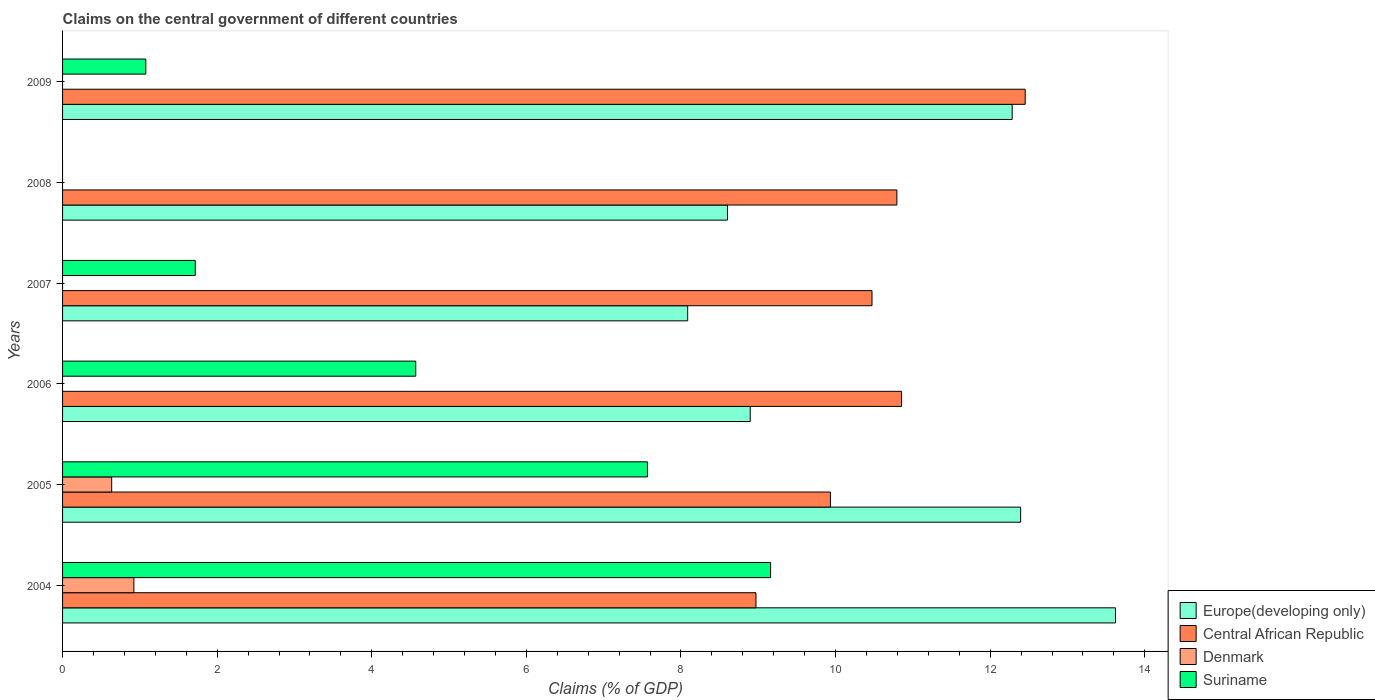How many different coloured bars are there?
Provide a succinct answer. 4. How many groups of bars are there?
Keep it short and to the point. 6. How many bars are there on the 6th tick from the top?
Your answer should be compact. 4. How many bars are there on the 4th tick from the bottom?
Provide a succinct answer. 3. What is the label of the 5th group of bars from the top?
Your answer should be very brief. 2005. In how many cases, is the number of bars for a given year not equal to the number of legend labels?
Your answer should be compact. 4. What is the percentage of GDP claimed on the central government in Denmark in 2007?
Offer a very short reply. 0. Across all years, what is the maximum percentage of GDP claimed on the central government in Suriname?
Your answer should be compact. 9.16. In which year was the percentage of GDP claimed on the central government in Central African Republic maximum?
Give a very brief answer. 2009. What is the total percentage of GDP claimed on the central government in Europe(developing only) in the graph?
Your response must be concise. 63.88. What is the difference between the percentage of GDP claimed on the central government in Central African Republic in 2004 and that in 2005?
Offer a terse response. -0.96. What is the difference between the percentage of GDP claimed on the central government in Denmark in 2004 and the percentage of GDP claimed on the central government in Europe(developing only) in 2006?
Your answer should be very brief. -7.97. What is the average percentage of GDP claimed on the central government in Central African Republic per year?
Provide a succinct answer. 10.58. In the year 2004, what is the difference between the percentage of GDP claimed on the central government in Europe(developing only) and percentage of GDP claimed on the central government in Central African Republic?
Provide a succinct answer. 4.65. What is the ratio of the percentage of GDP claimed on the central government in Europe(developing only) in 2006 to that in 2009?
Give a very brief answer. 0.72. Is the percentage of GDP claimed on the central government in Central African Republic in 2006 less than that in 2007?
Provide a short and direct response. No. Is the difference between the percentage of GDP claimed on the central government in Europe(developing only) in 2004 and 2008 greater than the difference between the percentage of GDP claimed on the central government in Central African Republic in 2004 and 2008?
Offer a terse response. Yes. What is the difference between the highest and the second highest percentage of GDP claimed on the central government in Suriname?
Your response must be concise. 1.59. What is the difference between the highest and the lowest percentage of GDP claimed on the central government in Suriname?
Keep it short and to the point. 9.16. In how many years, is the percentage of GDP claimed on the central government in Suriname greater than the average percentage of GDP claimed on the central government in Suriname taken over all years?
Provide a succinct answer. 3. Is the sum of the percentage of GDP claimed on the central government in Europe(developing only) in 2006 and 2008 greater than the maximum percentage of GDP claimed on the central government in Denmark across all years?
Your answer should be very brief. Yes. Is it the case that in every year, the sum of the percentage of GDP claimed on the central government in Europe(developing only) and percentage of GDP claimed on the central government in Central African Republic is greater than the percentage of GDP claimed on the central government in Suriname?
Your answer should be compact. Yes. How many bars are there?
Offer a very short reply. 19. What is the difference between two consecutive major ticks on the X-axis?
Keep it short and to the point. 2. Does the graph contain grids?
Offer a terse response. No. What is the title of the graph?
Provide a succinct answer. Claims on the central government of different countries. What is the label or title of the X-axis?
Offer a very short reply. Claims (% of GDP). What is the label or title of the Y-axis?
Ensure brevity in your answer.  Years. What is the Claims (% of GDP) in Europe(developing only) in 2004?
Ensure brevity in your answer.  13.62. What is the Claims (% of GDP) of Central African Republic in 2004?
Ensure brevity in your answer.  8.97. What is the Claims (% of GDP) in Denmark in 2004?
Provide a succinct answer. 0.92. What is the Claims (% of GDP) in Suriname in 2004?
Keep it short and to the point. 9.16. What is the Claims (% of GDP) of Europe(developing only) in 2005?
Provide a succinct answer. 12.39. What is the Claims (% of GDP) in Central African Republic in 2005?
Your response must be concise. 9.93. What is the Claims (% of GDP) of Denmark in 2005?
Offer a terse response. 0.64. What is the Claims (% of GDP) in Suriname in 2005?
Give a very brief answer. 7.57. What is the Claims (% of GDP) in Europe(developing only) in 2006?
Your answer should be very brief. 8.9. What is the Claims (% of GDP) of Central African Republic in 2006?
Your answer should be very brief. 10.85. What is the Claims (% of GDP) in Denmark in 2006?
Offer a terse response. 0. What is the Claims (% of GDP) of Suriname in 2006?
Your answer should be compact. 4.57. What is the Claims (% of GDP) in Europe(developing only) in 2007?
Offer a terse response. 8.09. What is the Claims (% of GDP) of Central African Republic in 2007?
Keep it short and to the point. 10.47. What is the Claims (% of GDP) of Suriname in 2007?
Give a very brief answer. 1.72. What is the Claims (% of GDP) of Europe(developing only) in 2008?
Make the answer very short. 8.6. What is the Claims (% of GDP) of Central African Republic in 2008?
Provide a succinct answer. 10.79. What is the Claims (% of GDP) of Denmark in 2008?
Provide a short and direct response. 0. What is the Claims (% of GDP) in Suriname in 2008?
Offer a terse response. 0. What is the Claims (% of GDP) in Europe(developing only) in 2009?
Offer a very short reply. 12.28. What is the Claims (% of GDP) in Central African Republic in 2009?
Provide a succinct answer. 12.45. What is the Claims (% of GDP) in Suriname in 2009?
Your answer should be compact. 1.08. Across all years, what is the maximum Claims (% of GDP) of Europe(developing only)?
Offer a terse response. 13.62. Across all years, what is the maximum Claims (% of GDP) in Central African Republic?
Keep it short and to the point. 12.45. Across all years, what is the maximum Claims (% of GDP) in Denmark?
Provide a short and direct response. 0.92. Across all years, what is the maximum Claims (% of GDP) of Suriname?
Make the answer very short. 9.16. Across all years, what is the minimum Claims (% of GDP) of Europe(developing only)?
Keep it short and to the point. 8.09. Across all years, what is the minimum Claims (% of GDP) of Central African Republic?
Provide a succinct answer. 8.97. Across all years, what is the minimum Claims (% of GDP) in Denmark?
Offer a very short reply. 0. What is the total Claims (% of GDP) in Europe(developing only) in the graph?
Provide a succinct answer. 63.88. What is the total Claims (% of GDP) of Central African Republic in the graph?
Ensure brevity in your answer.  63.48. What is the total Claims (% of GDP) in Denmark in the graph?
Provide a short and direct response. 1.56. What is the total Claims (% of GDP) of Suriname in the graph?
Make the answer very short. 24.09. What is the difference between the Claims (% of GDP) of Europe(developing only) in 2004 and that in 2005?
Offer a terse response. 1.23. What is the difference between the Claims (% of GDP) in Central African Republic in 2004 and that in 2005?
Your answer should be very brief. -0.96. What is the difference between the Claims (% of GDP) of Denmark in 2004 and that in 2005?
Provide a short and direct response. 0.29. What is the difference between the Claims (% of GDP) in Suriname in 2004 and that in 2005?
Your answer should be very brief. 1.59. What is the difference between the Claims (% of GDP) in Europe(developing only) in 2004 and that in 2006?
Offer a terse response. 4.73. What is the difference between the Claims (% of GDP) of Central African Republic in 2004 and that in 2006?
Your answer should be very brief. -1.88. What is the difference between the Claims (% of GDP) of Suriname in 2004 and that in 2006?
Offer a terse response. 4.59. What is the difference between the Claims (% of GDP) in Europe(developing only) in 2004 and that in 2007?
Offer a terse response. 5.53. What is the difference between the Claims (% of GDP) in Central African Republic in 2004 and that in 2007?
Your answer should be very brief. -1.5. What is the difference between the Claims (% of GDP) of Suriname in 2004 and that in 2007?
Make the answer very short. 7.44. What is the difference between the Claims (% of GDP) of Europe(developing only) in 2004 and that in 2008?
Keep it short and to the point. 5.02. What is the difference between the Claims (% of GDP) of Central African Republic in 2004 and that in 2008?
Ensure brevity in your answer.  -1.82. What is the difference between the Claims (% of GDP) of Europe(developing only) in 2004 and that in 2009?
Offer a terse response. 1.34. What is the difference between the Claims (% of GDP) of Central African Republic in 2004 and that in 2009?
Your answer should be compact. -3.48. What is the difference between the Claims (% of GDP) in Suriname in 2004 and that in 2009?
Provide a short and direct response. 8.08. What is the difference between the Claims (% of GDP) in Europe(developing only) in 2005 and that in 2006?
Offer a very short reply. 3.5. What is the difference between the Claims (% of GDP) in Central African Republic in 2005 and that in 2006?
Your answer should be very brief. -0.92. What is the difference between the Claims (% of GDP) of Suriname in 2005 and that in 2006?
Offer a terse response. 3. What is the difference between the Claims (% of GDP) of Europe(developing only) in 2005 and that in 2007?
Give a very brief answer. 4.31. What is the difference between the Claims (% of GDP) in Central African Republic in 2005 and that in 2007?
Provide a short and direct response. -0.54. What is the difference between the Claims (% of GDP) in Suriname in 2005 and that in 2007?
Offer a very short reply. 5.85. What is the difference between the Claims (% of GDP) in Europe(developing only) in 2005 and that in 2008?
Your answer should be very brief. 3.79. What is the difference between the Claims (% of GDP) in Central African Republic in 2005 and that in 2008?
Ensure brevity in your answer.  -0.86. What is the difference between the Claims (% of GDP) in Europe(developing only) in 2005 and that in 2009?
Provide a succinct answer. 0.11. What is the difference between the Claims (% of GDP) of Central African Republic in 2005 and that in 2009?
Your answer should be very brief. -2.52. What is the difference between the Claims (% of GDP) of Suriname in 2005 and that in 2009?
Ensure brevity in your answer.  6.49. What is the difference between the Claims (% of GDP) in Europe(developing only) in 2006 and that in 2007?
Ensure brevity in your answer.  0.81. What is the difference between the Claims (% of GDP) of Central African Republic in 2006 and that in 2007?
Your response must be concise. 0.38. What is the difference between the Claims (% of GDP) in Suriname in 2006 and that in 2007?
Your response must be concise. 2.85. What is the difference between the Claims (% of GDP) of Europe(developing only) in 2006 and that in 2008?
Offer a very short reply. 0.29. What is the difference between the Claims (% of GDP) of Central African Republic in 2006 and that in 2008?
Offer a very short reply. 0.06. What is the difference between the Claims (% of GDP) of Europe(developing only) in 2006 and that in 2009?
Your answer should be very brief. -3.39. What is the difference between the Claims (% of GDP) of Central African Republic in 2006 and that in 2009?
Provide a short and direct response. -1.6. What is the difference between the Claims (% of GDP) in Suriname in 2006 and that in 2009?
Make the answer very short. 3.49. What is the difference between the Claims (% of GDP) of Europe(developing only) in 2007 and that in 2008?
Provide a short and direct response. -0.51. What is the difference between the Claims (% of GDP) in Central African Republic in 2007 and that in 2008?
Your answer should be very brief. -0.32. What is the difference between the Claims (% of GDP) of Europe(developing only) in 2007 and that in 2009?
Offer a terse response. -4.2. What is the difference between the Claims (% of GDP) of Central African Republic in 2007 and that in 2009?
Give a very brief answer. -1.98. What is the difference between the Claims (% of GDP) of Suriname in 2007 and that in 2009?
Offer a terse response. 0.64. What is the difference between the Claims (% of GDP) in Europe(developing only) in 2008 and that in 2009?
Ensure brevity in your answer.  -3.68. What is the difference between the Claims (% of GDP) of Central African Republic in 2008 and that in 2009?
Provide a succinct answer. -1.66. What is the difference between the Claims (% of GDP) of Europe(developing only) in 2004 and the Claims (% of GDP) of Central African Republic in 2005?
Ensure brevity in your answer.  3.69. What is the difference between the Claims (% of GDP) in Europe(developing only) in 2004 and the Claims (% of GDP) in Denmark in 2005?
Your answer should be very brief. 12.99. What is the difference between the Claims (% of GDP) of Europe(developing only) in 2004 and the Claims (% of GDP) of Suriname in 2005?
Keep it short and to the point. 6.05. What is the difference between the Claims (% of GDP) in Central African Republic in 2004 and the Claims (% of GDP) in Denmark in 2005?
Your answer should be compact. 8.34. What is the difference between the Claims (% of GDP) of Central African Republic in 2004 and the Claims (% of GDP) of Suriname in 2005?
Offer a terse response. 1.4. What is the difference between the Claims (% of GDP) of Denmark in 2004 and the Claims (% of GDP) of Suriname in 2005?
Offer a very short reply. -6.64. What is the difference between the Claims (% of GDP) in Europe(developing only) in 2004 and the Claims (% of GDP) in Central African Republic in 2006?
Your response must be concise. 2.77. What is the difference between the Claims (% of GDP) of Europe(developing only) in 2004 and the Claims (% of GDP) of Suriname in 2006?
Make the answer very short. 9.05. What is the difference between the Claims (% of GDP) of Central African Republic in 2004 and the Claims (% of GDP) of Suriname in 2006?
Provide a succinct answer. 4.4. What is the difference between the Claims (% of GDP) in Denmark in 2004 and the Claims (% of GDP) in Suriname in 2006?
Provide a short and direct response. -3.65. What is the difference between the Claims (% of GDP) of Europe(developing only) in 2004 and the Claims (% of GDP) of Central African Republic in 2007?
Offer a terse response. 3.15. What is the difference between the Claims (% of GDP) in Europe(developing only) in 2004 and the Claims (% of GDP) in Suriname in 2007?
Keep it short and to the point. 11.9. What is the difference between the Claims (% of GDP) of Central African Republic in 2004 and the Claims (% of GDP) of Suriname in 2007?
Offer a very short reply. 7.25. What is the difference between the Claims (% of GDP) of Denmark in 2004 and the Claims (% of GDP) of Suriname in 2007?
Your answer should be compact. -0.79. What is the difference between the Claims (% of GDP) of Europe(developing only) in 2004 and the Claims (% of GDP) of Central African Republic in 2008?
Offer a very short reply. 2.83. What is the difference between the Claims (% of GDP) in Europe(developing only) in 2004 and the Claims (% of GDP) in Central African Republic in 2009?
Provide a succinct answer. 1.17. What is the difference between the Claims (% of GDP) of Europe(developing only) in 2004 and the Claims (% of GDP) of Suriname in 2009?
Provide a succinct answer. 12.54. What is the difference between the Claims (% of GDP) in Central African Republic in 2004 and the Claims (% of GDP) in Suriname in 2009?
Your answer should be compact. 7.89. What is the difference between the Claims (% of GDP) in Denmark in 2004 and the Claims (% of GDP) in Suriname in 2009?
Provide a short and direct response. -0.15. What is the difference between the Claims (% of GDP) of Europe(developing only) in 2005 and the Claims (% of GDP) of Central African Republic in 2006?
Keep it short and to the point. 1.54. What is the difference between the Claims (% of GDP) of Europe(developing only) in 2005 and the Claims (% of GDP) of Suriname in 2006?
Your answer should be compact. 7.83. What is the difference between the Claims (% of GDP) of Central African Republic in 2005 and the Claims (% of GDP) of Suriname in 2006?
Provide a short and direct response. 5.36. What is the difference between the Claims (% of GDP) in Denmark in 2005 and the Claims (% of GDP) in Suriname in 2006?
Your answer should be compact. -3.93. What is the difference between the Claims (% of GDP) in Europe(developing only) in 2005 and the Claims (% of GDP) in Central African Republic in 2007?
Your answer should be compact. 1.92. What is the difference between the Claims (% of GDP) of Europe(developing only) in 2005 and the Claims (% of GDP) of Suriname in 2007?
Provide a short and direct response. 10.68. What is the difference between the Claims (% of GDP) of Central African Republic in 2005 and the Claims (% of GDP) of Suriname in 2007?
Your answer should be compact. 8.22. What is the difference between the Claims (% of GDP) of Denmark in 2005 and the Claims (% of GDP) of Suriname in 2007?
Your response must be concise. -1.08. What is the difference between the Claims (% of GDP) in Europe(developing only) in 2005 and the Claims (% of GDP) in Central African Republic in 2008?
Keep it short and to the point. 1.6. What is the difference between the Claims (% of GDP) in Europe(developing only) in 2005 and the Claims (% of GDP) in Central African Republic in 2009?
Offer a very short reply. -0.06. What is the difference between the Claims (% of GDP) in Europe(developing only) in 2005 and the Claims (% of GDP) in Suriname in 2009?
Provide a succinct answer. 11.32. What is the difference between the Claims (% of GDP) in Central African Republic in 2005 and the Claims (% of GDP) in Suriname in 2009?
Keep it short and to the point. 8.86. What is the difference between the Claims (% of GDP) in Denmark in 2005 and the Claims (% of GDP) in Suriname in 2009?
Offer a very short reply. -0.44. What is the difference between the Claims (% of GDP) of Europe(developing only) in 2006 and the Claims (% of GDP) of Central African Republic in 2007?
Your answer should be compact. -1.58. What is the difference between the Claims (% of GDP) of Europe(developing only) in 2006 and the Claims (% of GDP) of Suriname in 2007?
Provide a short and direct response. 7.18. What is the difference between the Claims (% of GDP) in Central African Republic in 2006 and the Claims (% of GDP) in Suriname in 2007?
Your answer should be compact. 9.14. What is the difference between the Claims (% of GDP) of Europe(developing only) in 2006 and the Claims (% of GDP) of Central African Republic in 2008?
Your response must be concise. -1.9. What is the difference between the Claims (% of GDP) of Europe(developing only) in 2006 and the Claims (% of GDP) of Central African Republic in 2009?
Your answer should be very brief. -3.56. What is the difference between the Claims (% of GDP) in Europe(developing only) in 2006 and the Claims (% of GDP) in Suriname in 2009?
Provide a short and direct response. 7.82. What is the difference between the Claims (% of GDP) in Central African Republic in 2006 and the Claims (% of GDP) in Suriname in 2009?
Make the answer very short. 9.78. What is the difference between the Claims (% of GDP) in Europe(developing only) in 2007 and the Claims (% of GDP) in Central African Republic in 2008?
Your answer should be compact. -2.71. What is the difference between the Claims (% of GDP) of Europe(developing only) in 2007 and the Claims (% of GDP) of Central African Republic in 2009?
Your response must be concise. -4.37. What is the difference between the Claims (% of GDP) of Europe(developing only) in 2007 and the Claims (% of GDP) of Suriname in 2009?
Give a very brief answer. 7.01. What is the difference between the Claims (% of GDP) in Central African Republic in 2007 and the Claims (% of GDP) in Suriname in 2009?
Ensure brevity in your answer.  9.39. What is the difference between the Claims (% of GDP) in Europe(developing only) in 2008 and the Claims (% of GDP) in Central African Republic in 2009?
Ensure brevity in your answer.  -3.85. What is the difference between the Claims (% of GDP) of Europe(developing only) in 2008 and the Claims (% of GDP) of Suriname in 2009?
Your response must be concise. 7.52. What is the difference between the Claims (% of GDP) in Central African Republic in 2008 and the Claims (% of GDP) in Suriname in 2009?
Offer a very short reply. 9.72. What is the average Claims (% of GDP) in Europe(developing only) per year?
Your answer should be compact. 10.65. What is the average Claims (% of GDP) of Central African Republic per year?
Your answer should be compact. 10.58. What is the average Claims (% of GDP) of Denmark per year?
Provide a succinct answer. 0.26. What is the average Claims (% of GDP) in Suriname per year?
Your response must be concise. 4.01. In the year 2004, what is the difference between the Claims (% of GDP) in Europe(developing only) and Claims (% of GDP) in Central African Republic?
Offer a very short reply. 4.65. In the year 2004, what is the difference between the Claims (% of GDP) in Europe(developing only) and Claims (% of GDP) in Denmark?
Provide a short and direct response. 12.7. In the year 2004, what is the difference between the Claims (% of GDP) of Europe(developing only) and Claims (% of GDP) of Suriname?
Your response must be concise. 4.46. In the year 2004, what is the difference between the Claims (% of GDP) in Central African Republic and Claims (% of GDP) in Denmark?
Provide a short and direct response. 8.05. In the year 2004, what is the difference between the Claims (% of GDP) in Central African Republic and Claims (% of GDP) in Suriname?
Your answer should be compact. -0.19. In the year 2004, what is the difference between the Claims (% of GDP) in Denmark and Claims (% of GDP) in Suriname?
Provide a succinct answer. -8.24. In the year 2005, what is the difference between the Claims (% of GDP) of Europe(developing only) and Claims (% of GDP) of Central African Republic?
Your answer should be compact. 2.46. In the year 2005, what is the difference between the Claims (% of GDP) in Europe(developing only) and Claims (% of GDP) in Denmark?
Give a very brief answer. 11.76. In the year 2005, what is the difference between the Claims (% of GDP) in Europe(developing only) and Claims (% of GDP) in Suriname?
Provide a short and direct response. 4.83. In the year 2005, what is the difference between the Claims (% of GDP) of Central African Republic and Claims (% of GDP) of Denmark?
Give a very brief answer. 9.3. In the year 2005, what is the difference between the Claims (% of GDP) in Central African Republic and Claims (% of GDP) in Suriname?
Give a very brief answer. 2.37. In the year 2005, what is the difference between the Claims (% of GDP) in Denmark and Claims (% of GDP) in Suriname?
Give a very brief answer. -6.93. In the year 2006, what is the difference between the Claims (% of GDP) in Europe(developing only) and Claims (% of GDP) in Central African Republic?
Offer a very short reply. -1.96. In the year 2006, what is the difference between the Claims (% of GDP) of Europe(developing only) and Claims (% of GDP) of Suriname?
Your response must be concise. 4.33. In the year 2006, what is the difference between the Claims (% of GDP) of Central African Republic and Claims (% of GDP) of Suriname?
Provide a short and direct response. 6.29. In the year 2007, what is the difference between the Claims (% of GDP) of Europe(developing only) and Claims (% of GDP) of Central African Republic?
Make the answer very short. -2.38. In the year 2007, what is the difference between the Claims (% of GDP) in Europe(developing only) and Claims (% of GDP) in Suriname?
Offer a terse response. 6.37. In the year 2007, what is the difference between the Claims (% of GDP) of Central African Republic and Claims (% of GDP) of Suriname?
Your response must be concise. 8.75. In the year 2008, what is the difference between the Claims (% of GDP) of Europe(developing only) and Claims (% of GDP) of Central African Republic?
Your answer should be compact. -2.19. In the year 2009, what is the difference between the Claims (% of GDP) in Europe(developing only) and Claims (% of GDP) in Central African Republic?
Offer a very short reply. -0.17. In the year 2009, what is the difference between the Claims (% of GDP) in Europe(developing only) and Claims (% of GDP) in Suriname?
Provide a short and direct response. 11.21. In the year 2009, what is the difference between the Claims (% of GDP) of Central African Republic and Claims (% of GDP) of Suriname?
Provide a succinct answer. 11.38. What is the ratio of the Claims (% of GDP) in Europe(developing only) in 2004 to that in 2005?
Your answer should be compact. 1.1. What is the ratio of the Claims (% of GDP) in Central African Republic in 2004 to that in 2005?
Make the answer very short. 0.9. What is the ratio of the Claims (% of GDP) in Denmark in 2004 to that in 2005?
Offer a very short reply. 1.45. What is the ratio of the Claims (% of GDP) of Suriname in 2004 to that in 2005?
Provide a short and direct response. 1.21. What is the ratio of the Claims (% of GDP) in Europe(developing only) in 2004 to that in 2006?
Make the answer very short. 1.53. What is the ratio of the Claims (% of GDP) in Central African Republic in 2004 to that in 2006?
Ensure brevity in your answer.  0.83. What is the ratio of the Claims (% of GDP) of Suriname in 2004 to that in 2006?
Make the answer very short. 2. What is the ratio of the Claims (% of GDP) of Europe(developing only) in 2004 to that in 2007?
Offer a terse response. 1.68. What is the ratio of the Claims (% of GDP) in Central African Republic in 2004 to that in 2007?
Give a very brief answer. 0.86. What is the ratio of the Claims (% of GDP) of Suriname in 2004 to that in 2007?
Your answer should be compact. 5.33. What is the ratio of the Claims (% of GDP) in Europe(developing only) in 2004 to that in 2008?
Make the answer very short. 1.58. What is the ratio of the Claims (% of GDP) of Central African Republic in 2004 to that in 2008?
Your answer should be very brief. 0.83. What is the ratio of the Claims (% of GDP) of Europe(developing only) in 2004 to that in 2009?
Provide a short and direct response. 1.11. What is the ratio of the Claims (% of GDP) of Central African Republic in 2004 to that in 2009?
Provide a short and direct response. 0.72. What is the ratio of the Claims (% of GDP) in Suriname in 2004 to that in 2009?
Provide a short and direct response. 8.51. What is the ratio of the Claims (% of GDP) of Europe(developing only) in 2005 to that in 2006?
Keep it short and to the point. 1.39. What is the ratio of the Claims (% of GDP) of Central African Republic in 2005 to that in 2006?
Provide a succinct answer. 0.92. What is the ratio of the Claims (% of GDP) in Suriname in 2005 to that in 2006?
Provide a succinct answer. 1.66. What is the ratio of the Claims (% of GDP) of Europe(developing only) in 2005 to that in 2007?
Give a very brief answer. 1.53. What is the ratio of the Claims (% of GDP) in Central African Republic in 2005 to that in 2007?
Offer a terse response. 0.95. What is the ratio of the Claims (% of GDP) in Suriname in 2005 to that in 2007?
Your answer should be compact. 4.41. What is the ratio of the Claims (% of GDP) in Europe(developing only) in 2005 to that in 2008?
Offer a terse response. 1.44. What is the ratio of the Claims (% of GDP) of Central African Republic in 2005 to that in 2008?
Your answer should be compact. 0.92. What is the ratio of the Claims (% of GDP) of Europe(developing only) in 2005 to that in 2009?
Provide a short and direct response. 1.01. What is the ratio of the Claims (% of GDP) in Central African Republic in 2005 to that in 2009?
Make the answer very short. 0.8. What is the ratio of the Claims (% of GDP) in Suriname in 2005 to that in 2009?
Ensure brevity in your answer.  7.03. What is the ratio of the Claims (% of GDP) of Europe(developing only) in 2006 to that in 2007?
Offer a terse response. 1.1. What is the ratio of the Claims (% of GDP) of Central African Republic in 2006 to that in 2007?
Give a very brief answer. 1.04. What is the ratio of the Claims (% of GDP) in Suriname in 2006 to that in 2007?
Provide a short and direct response. 2.66. What is the ratio of the Claims (% of GDP) of Europe(developing only) in 2006 to that in 2008?
Offer a very short reply. 1.03. What is the ratio of the Claims (% of GDP) in Central African Republic in 2006 to that in 2008?
Offer a terse response. 1.01. What is the ratio of the Claims (% of GDP) of Europe(developing only) in 2006 to that in 2009?
Provide a succinct answer. 0.72. What is the ratio of the Claims (% of GDP) of Central African Republic in 2006 to that in 2009?
Offer a very short reply. 0.87. What is the ratio of the Claims (% of GDP) in Suriname in 2006 to that in 2009?
Your answer should be very brief. 4.24. What is the ratio of the Claims (% of GDP) in Europe(developing only) in 2007 to that in 2008?
Provide a succinct answer. 0.94. What is the ratio of the Claims (% of GDP) in Central African Republic in 2007 to that in 2008?
Your answer should be very brief. 0.97. What is the ratio of the Claims (% of GDP) in Europe(developing only) in 2007 to that in 2009?
Your response must be concise. 0.66. What is the ratio of the Claims (% of GDP) of Central African Republic in 2007 to that in 2009?
Your answer should be very brief. 0.84. What is the ratio of the Claims (% of GDP) in Suriname in 2007 to that in 2009?
Offer a terse response. 1.59. What is the ratio of the Claims (% of GDP) in Europe(developing only) in 2008 to that in 2009?
Your answer should be very brief. 0.7. What is the ratio of the Claims (% of GDP) in Central African Republic in 2008 to that in 2009?
Your response must be concise. 0.87. What is the difference between the highest and the second highest Claims (% of GDP) in Europe(developing only)?
Provide a short and direct response. 1.23. What is the difference between the highest and the second highest Claims (% of GDP) in Central African Republic?
Offer a terse response. 1.6. What is the difference between the highest and the second highest Claims (% of GDP) of Suriname?
Ensure brevity in your answer.  1.59. What is the difference between the highest and the lowest Claims (% of GDP) in Europe(developing only)?
Your answer should be very brief. 5.53. What is the difference between the highest and the lowest Claims (% of GDP) in Central African Republic?
Give a very brief answer. 3.48. What is the difference between the highest and the lowest Claims (% of GDP) of Denmark?
Your answer should be compact. 0.92. What is the difference between the highest and the lowest Claims (% of GDP) in Suriname?
Give a very brief answer. 9.16. 